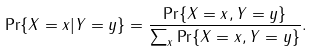Convert formula to latex. <formula><loc_0><loc_0><loc_500><loc_500>\Pr \{ X = x | Y = y \} = \frac { \Pr \{ X = x , Y = y \} } { \sum _ { x } \Pr \{ X = x , Y = y \} } .</formula> 